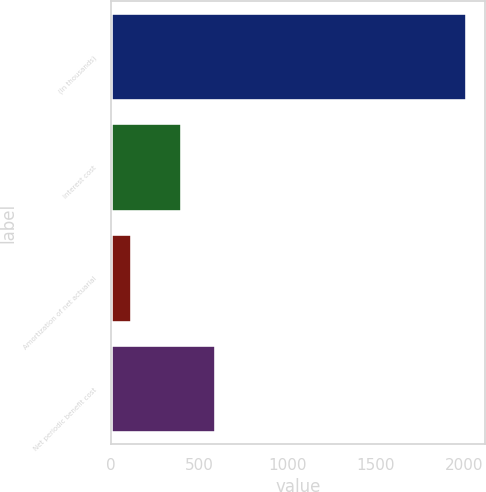Convert chart to OTSL. <chart><loc_0><loc_0><loc_500><loc_500><bar_chart><fcel>(In thousands)<fcel>Interest cost<fcel>Amortization of net actuarial<fcel>Net periodic benefit cost<nl><fcel>2016<fcel>402<fcel>117<fcel>591.9<nl></chart> 